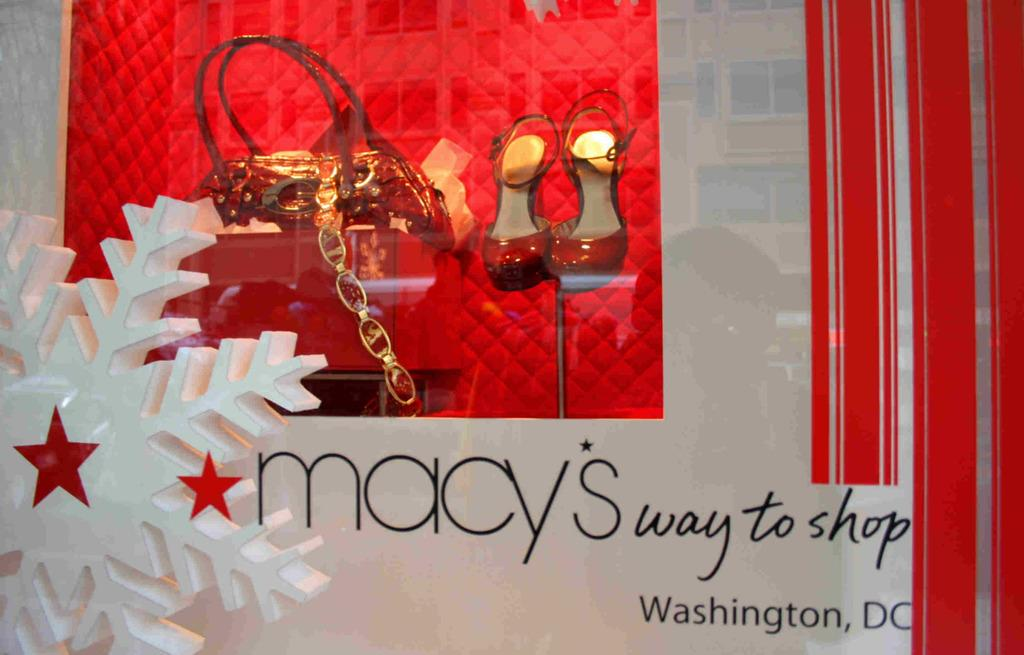What is one item that can be seen in the image? There is a bag in the image. What other item is visible in the image? There is a pair of shoes in the image. How are the bag and shoes stored in the image? The bag and shoes are kept in a case. What is covering the case in the image? There is a glass covering the case. What type of soup is being served by the laborer on the mountain in the image? There is no laborer, mountain, or soup present in the image. 